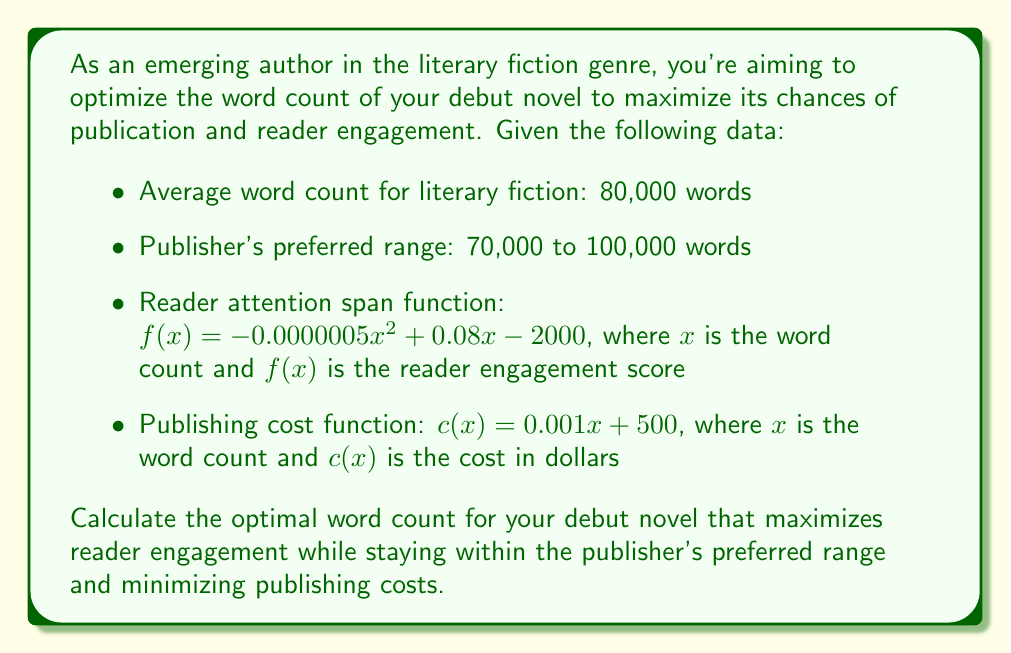Provide a solution to this math problem. To solve this optimization problem, we'll follow these steps:

1. Determine the domain of our function based on the publisher's preferred range:
   $70,000 \leq x \leq 100,000$

2. Find the maximum of the reader attention span function within this range:
   $f(x) = -0.0000005x^2 + 0.08x - 2000$
   
   To find the maximum, we differentiate $f(x)$ and set it to zero:
   $$f'(x) = -0.000001x + 0.08 = 0$$
   $$x = 80,000$$

   This critical point falls within our domain, so it's a potential maximum.

3. Check the endpoints of our domain:
   $f(70,000) = 1,750$
   $f(80,000) = 1,800$
   $f(100,000) = 1,500$

   The maximum occurs at $x = 80,000$ words.

4. Consider the publishing cost function:
   $c(x) = 0.001x + 500$
   
   This function increases linearly with word count, so a lower word count will always result in a lower cost.

5. Balance reader engagement and publishing costs:
   Since the optimal word count for reader engagement (80,000) coincides with the average word count for literary fiction and falls within the publisher's preferred range, it represents a good balance between maximizing engagement and keeping costs reasonable.

Therefore, the optimal word count for the debut novel is 80,000 words.
Answer: 80,000 words 